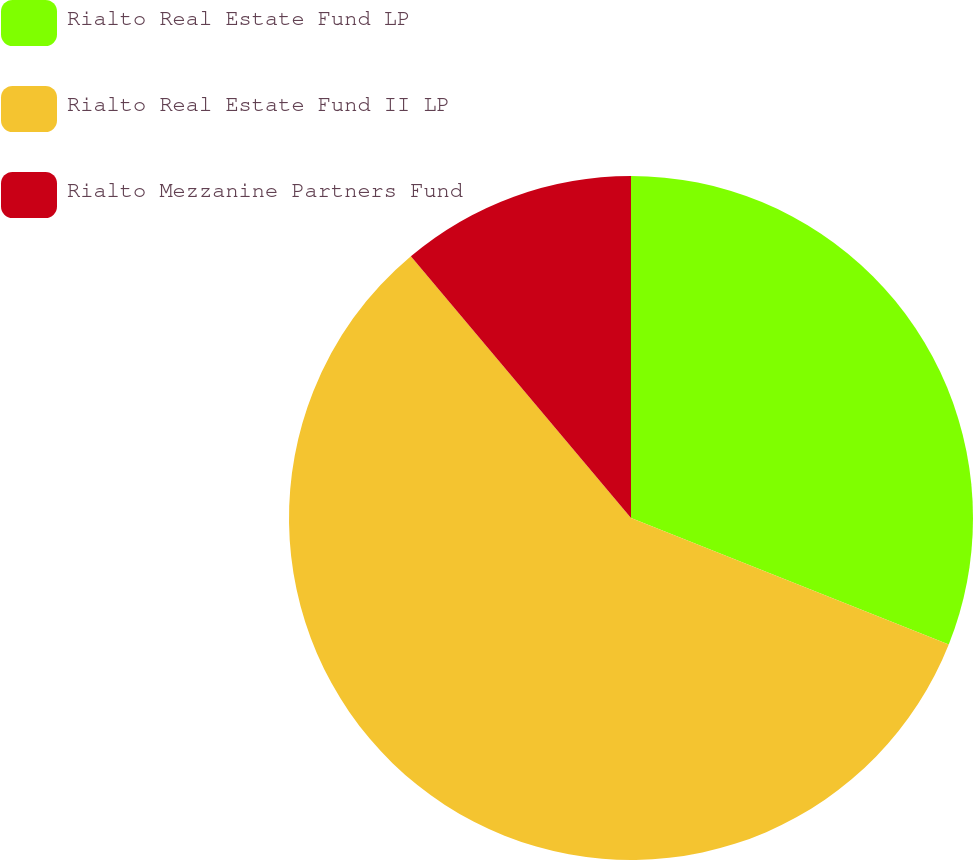<chart> <loc_0><loc_0><loc_500><loc_500><pie_chart><fcel>Rialto Real Estate Fund LP<fcel>Rialto Real Estate Fund II LP<fcel>Rialto Mezzanine Partners Fund<nl><fcel>31.03%<fcel>57.84%<fcel>11.13%<nl></chart> 